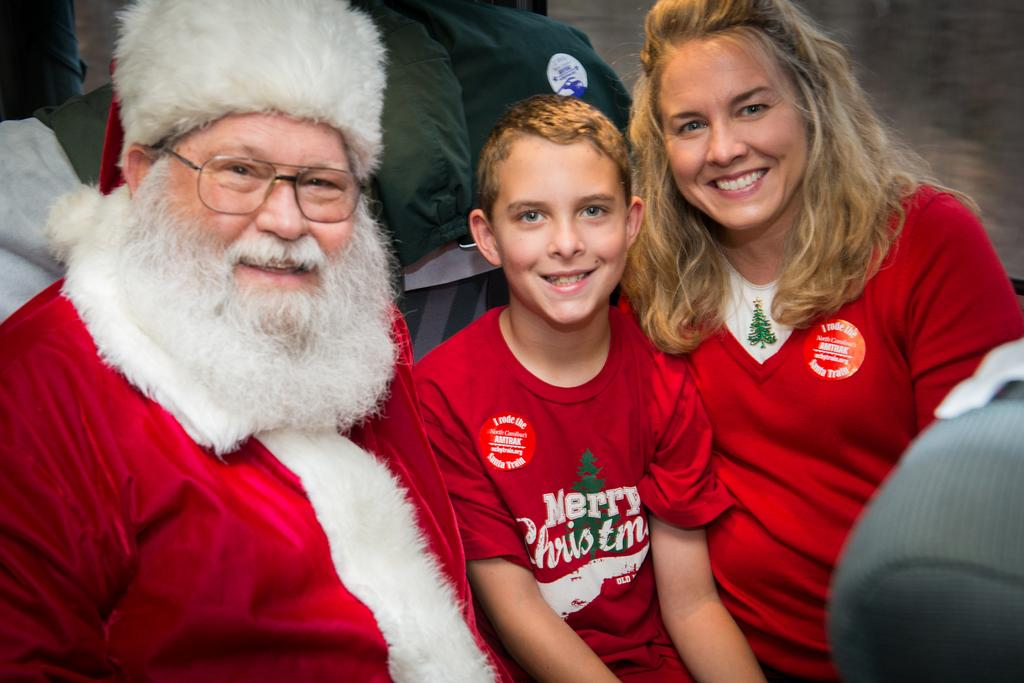<image>
Present a compact description of the photo's key features. Boy wearing a red shirt that says Merry Christmas posing with Santa. 